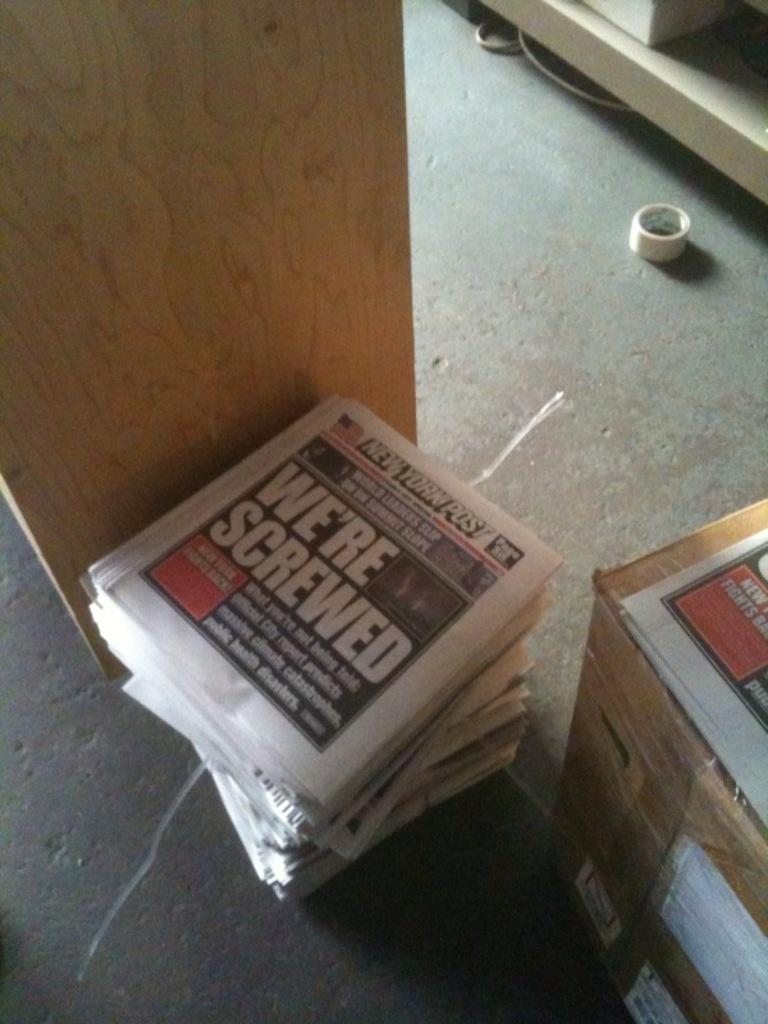<image>
Relay a brief, clear account of the picture shown. A stack of news paper from New York post with a headline we're screwed. 